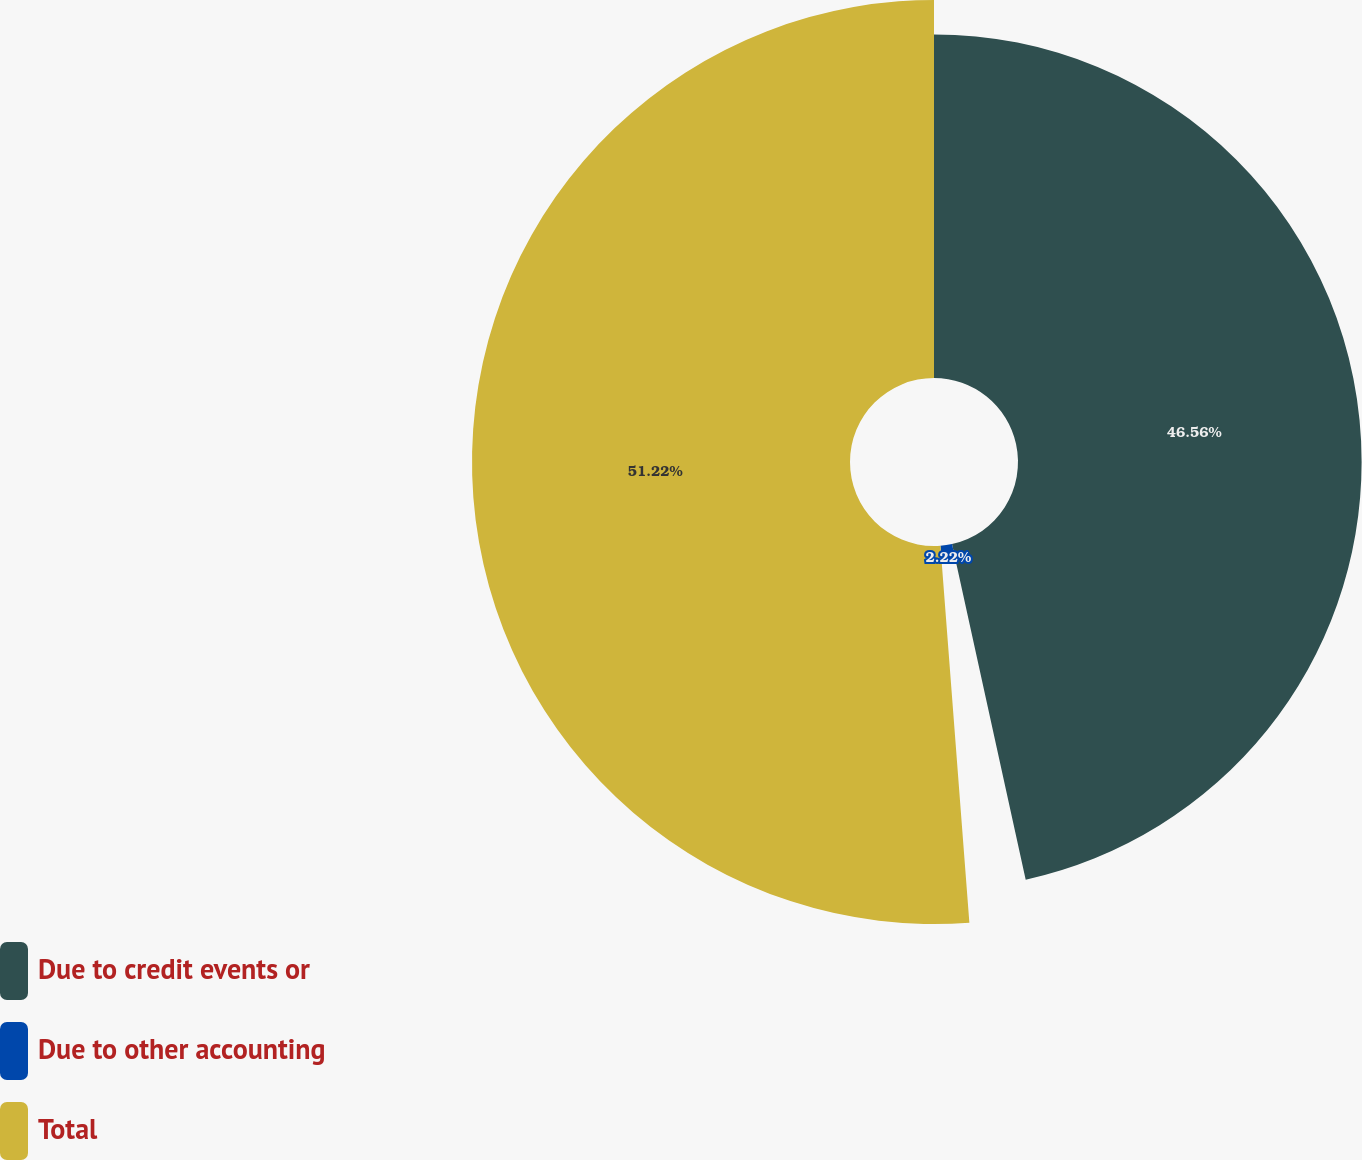<chart> <loc_0><loc_0><loc_500><loc_500><pie_chart><fcel>Due to credit events or<fcel>Due to other accounting<fcel>Total<nl><fcel>46.56%<fcel>2.22%<fcel>51.22%<nl></chart> 